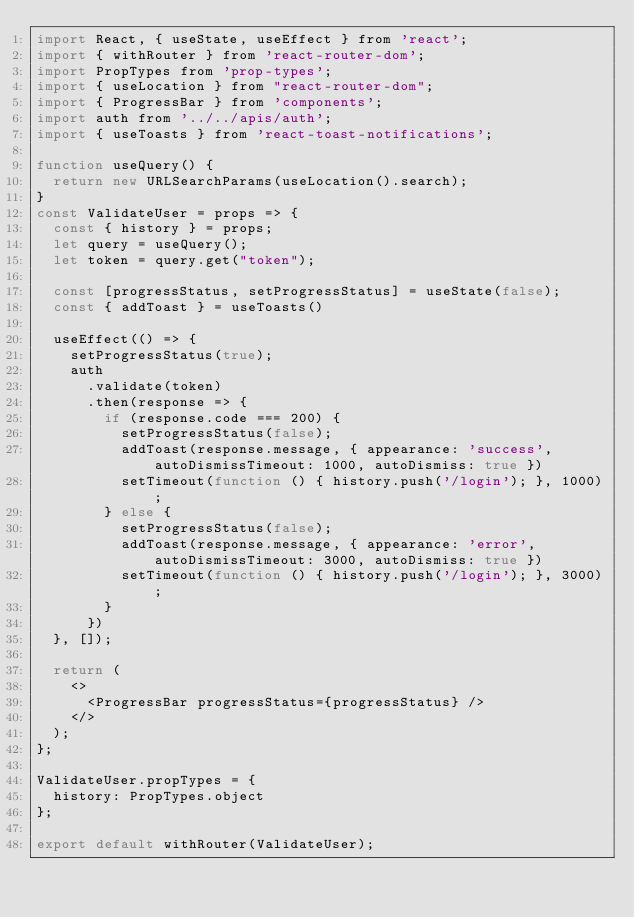<code> <loc_0><loc_0><loc_500><loc_500><_JavaScript_>import React, { useState, useEffect } from 'react';
import { withRouter } from 'react-router-dom';
import PropTypes from 'prop-types';
import { useLocation } from "react-router-dom";
import { ProgressBar } from 'components';
import auth from '../../apis/auth';
import { useToasts } from 'react-toast-notifications';

function useQuery() {
  return new URLSearchParams(useLocation().search);
}
const ValidateUser = props => {
  const { history } = props;
  let query = useQuery();
  let token = query.get("token");
  
  const [progressStatus, setProgressStatus] = useState(false);
  const { addToast } = useToasts()

  useEffect(() => {
    setProgressStatus(true);
    auth
      .validate(token)
      .then(response => {
        if (response.code === 200) {
          setProgressStatus(false);
          addToast(response.message, { appearance: 'success', autoDismissTimeout: 1000, autoDismiss: true })
          setTimeout(function () { history.push('/login'); }, 1000);
        } else {
          setProgressStatus(false);
          addToast(response.message, { appearance: 'error', autoDismissTimeout: 3000, autoDismiss: true })
          setTimeout(function () { history.push('/login'); }, 3000);
        }
      })
  }, []);

  return (
    <>
      <ProgressBar progressStatus={progressStatus} />
    </>
  );
};

ValidateUser.propTypes = {
  history: PropTypes.object
};

export default withRouter(ValidateUser);
</code> 